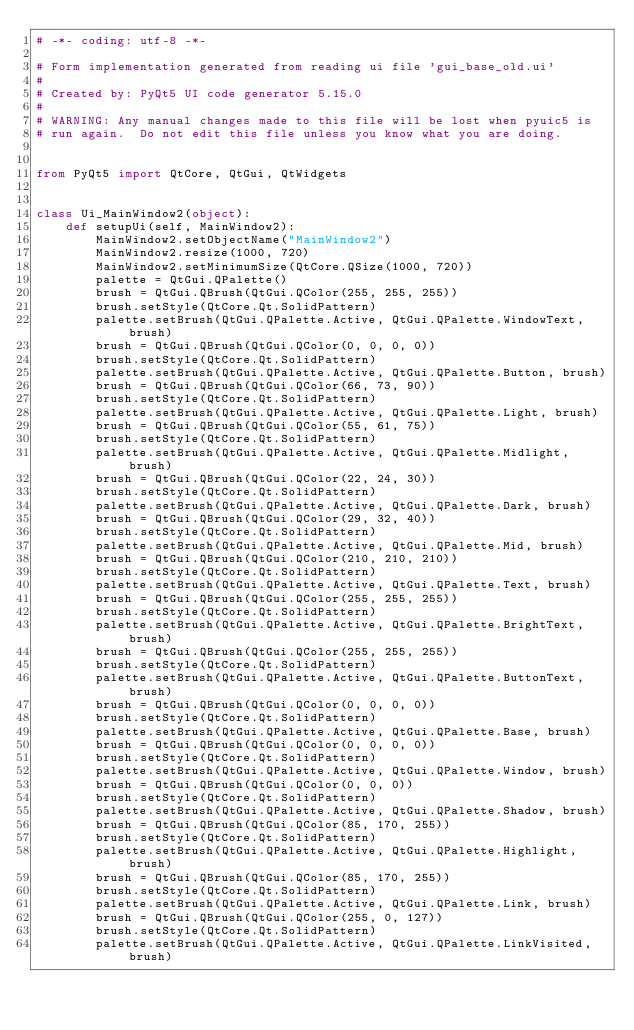<code> <loc_0><loc_0><loc_500><loc_500><_Python_># -*- coding: utf-8 -*-

# Form implementation generated from reading ui file 'gui_base_old.ui'
#
# Created by: PyQt5 UI code generator 5.15.0
#
# WARNING: Any manual changes made to this file will be lost when pyuic5 is
# run again.  Do not edit this file unless you know what you are doing.


from PyQt5 import QtCore, QtGui, QtWidgets


class Ui_MainWindow2(object):
    def setupUi(self, MainWindow2):
        MainWindow2.setObjectName("MainWindow2")
        MainWindow2.resize(1000, 720)
        MainWindow2.setMinimumSize(QtCore.QSize(1000, 720))
        palette = QtGui.QPalette()
        brush = QtGui.QBrush(QtGui.QColor(255, 255, 255))
        brush.setStyle(QtCore.Qt.SolidPattern)
        palette.setBrush(QtGui.QPalette.Active, QtGui.QPalette.WindowText, brush)
        brush = QtGui.QBrush(QtGui.QColor(0, 0, 0, 0))
        brush.setStyle(QtCore.Qt.SolidPattern)
        palette.setBrush(QtGui.QPalette.Active, QtGui.QPalette.Button, brush)
        brush = QtGui.QBrush(QtGui.QColor(66, 73, 90))
        brush.setStyle(QtCore.Qt.SolidPattern)
        palette.setBrush(QtGui.QPalette.Active, QtGui.QPalette.Light, brush)
        brush = QtGui.QBrush(QtGui.QColor(55, 61, 75))
        brush.setStyle(QtCore.Qt.SolidPattern)
        palette.setBrush(QtGui.QPalette.Active, QtGui.QPalette.Midlight, brush)
        brush = QtGui.QBrush(QtGui.QColor(22, 24, 30))
        brush.setStyle(QtCore.Qt.SolidPattern)
        palette.setBrush(QtGui.QPalette.Active, QtGui.QPalette.Dark, brush)
        brush = QtGui.QBrush(QtGui.QColor(29, 32, 40))
        brush.setStyle(QtCore.Qt.SolidPattern)
        palette.setBrush(QtGui.QPalette.Active, QtGui.QPalette.Mid, brush)
        brush = QtGui.QBrush(QtGui.QColor(210, 210, 210))
        brush.setStyle(QtCore.Qt.SolidPattern)
        palette.setBrush(QtGui.QPalette.Active, QtGui.QPalette.Text, brush)
        brush = QtGui.QBrush(QtGui.QColor(255, 255, 255))
        brush.setStyle(QtCore.Qt.SolidPattern)
        palette.setBrush(QtGui.QPalette.Active, QtGui.QPalette.BrightText, brush)
        brush = QtGui.QBrush(QtGui.QColor(255, 255, 255))
        brush.setStyle(QtCore.Qt.SolidPattern)
        palette.setBrush(QtGui.QPalette.Active, QtGui.QPalette.ButtonText, brush)
        brush = QtGui.QBrush(QtGui.QColor(0, 0, 0, 0))
        brush.setStyle(QtCore.Qt.SolidPattern)
        palette.setBrush(QtGui.QPalette.Active, QtGui.QPalette.Base, brush)
        brush = QtGui.QBrush(QtGui.QColor(0, 0, 0, 0))
        brush.setStyle(QtCore.Qt.SolidPattern)
        palette.setBrush(QtGui.QPalette.Active, QtGui.QPalette.Window, brush)
        brush = QtGui.QBrush(QtGui.QColor(0, 0, 0))
        brush.setStyle(QtCore.Qt.SolidPattern)
        palette.setBrush(QtGui.QPalette.Active, QtGui.QPalette.Shadow, brush)
        brush = QtGui.QBrush(QtGui.QColor(85, 170, 255))
        brush.setStyle(QtCore.Qt.SolidPattern)
        palette.setBrush(QtGui.QPalette.Active, QtGui.QPalette.Highlight, brush)
        brush = QtGui.QBrush(QtGui.QColor(85, 170, 255))
        brush.setStyle(QtCore.Qt.SolidPattern)
        palette.setBrush(QtGui.QPalette.Active, QtGui.QPalette.Link, brush)
        brush = QtGui.QBrush(QtGui.QColor(255, 0, 127))
        brush.setStyle(QtCore.Qt.SolidPattern)
        palette.setBrush(QtGui.QPalette.Active, QtGui.QPalette.LinkVisited, brush)</code> 